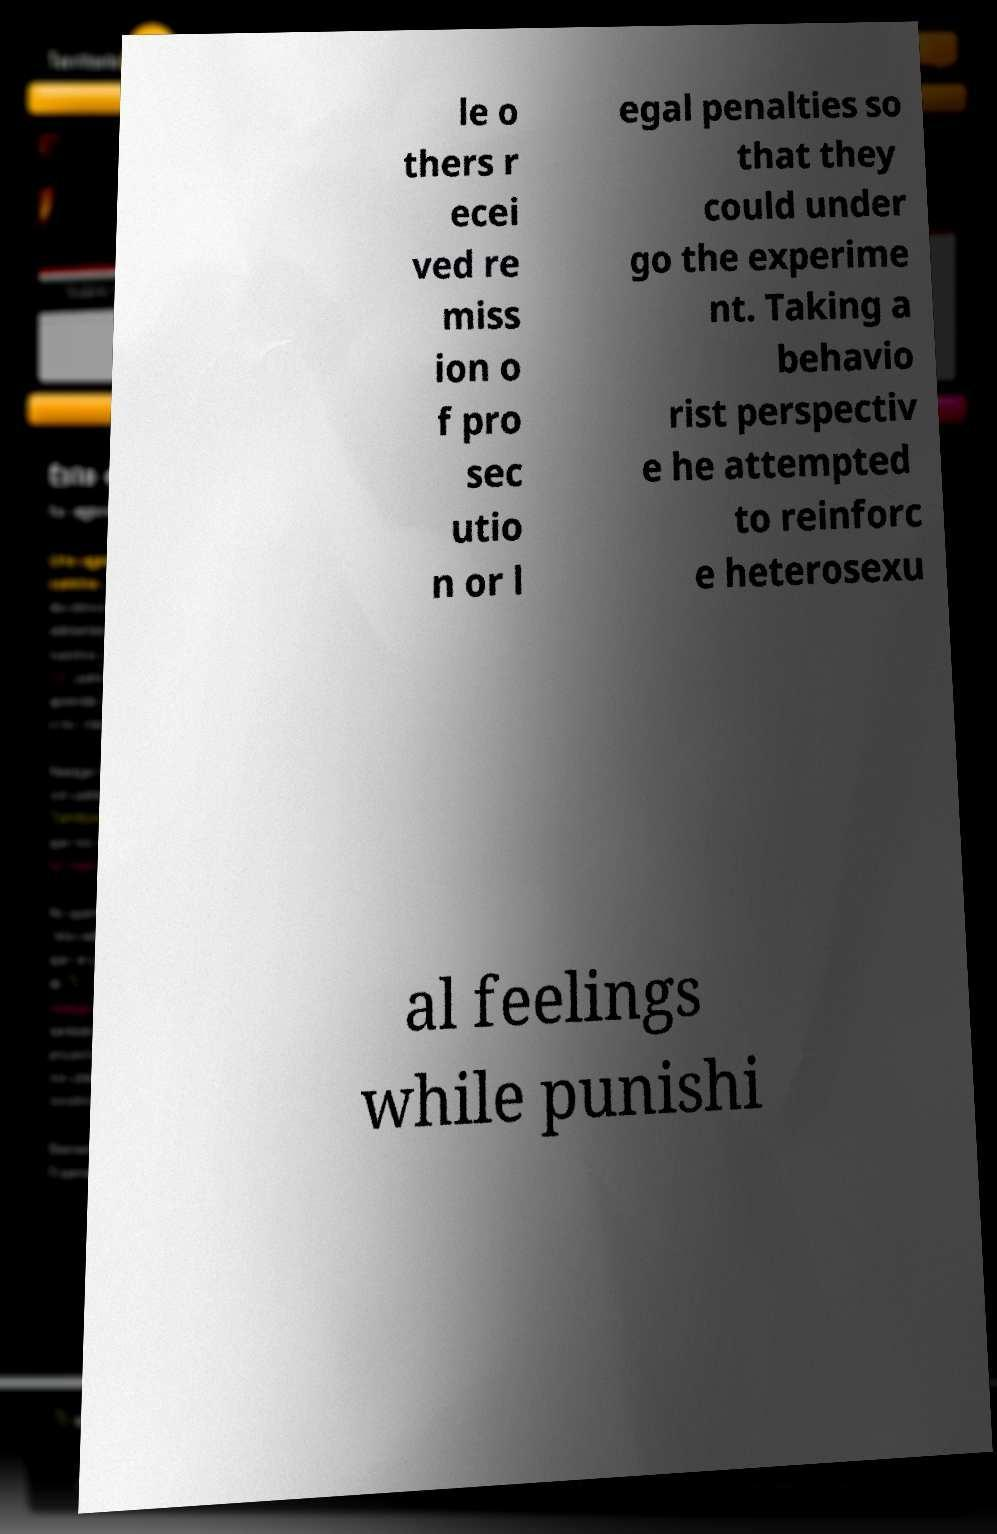Please identify and transcribe the text found in this image. le o thers r ecei ved re miss ion o f pro sec utio n or l egal penalties so that they could under go the experime nt. Taking a behavio rist perspectiv e he attempted to reinforc e heterosexu al feelings while punishi 